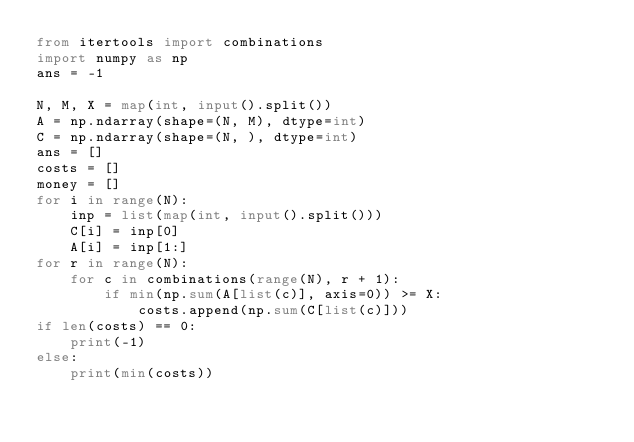Convert code to text. <code><loc_0><loc_0><loc_500><loc_500><_Python_>from itertools import combinations
import numpy as np
ans = -1

N, M, X = map(int, input().split())
A = np.ndarray(shape=(N, M), dtype=int)
C = np.ndarray(shape=(N, ), dtype=int)
ans = []
costs = []
money = []
for i in range(N):
    inp = list(map(int, input().split()))
    C[i] = inp[0]
    A[i] = inp[1:]
for r in range(N):
    for c in combinations(range(N), r + 1):
        if min(np.sum(A[list(c)], axis=0)) >= X:
            costs.append(np.sum(C[list(c)]))
if len(costs) == 0:
    print(-1)
else:
    print(min(costs))</code> 